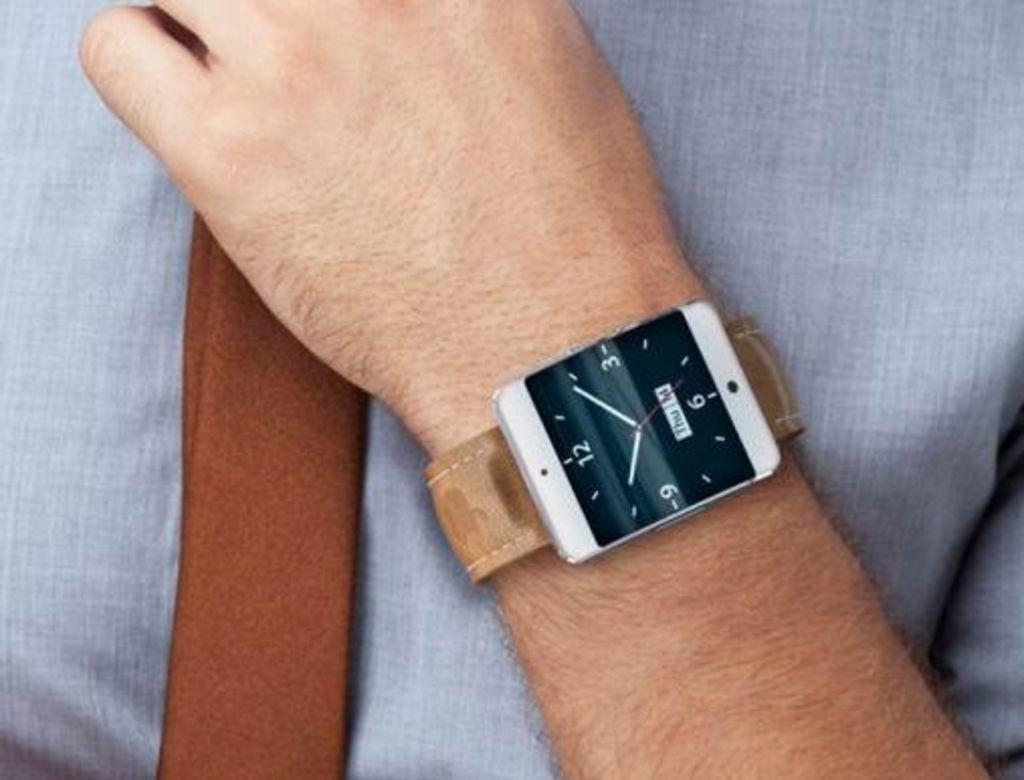<image>
Create a compact narrative representing the image presented. A clock shows that it is "Thu"(or Thursday). 